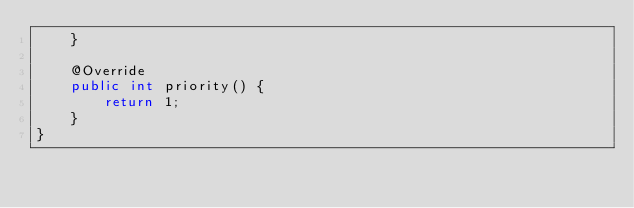Convert code to text. <code><loc_0><loc_0><loc_500><loc_500><_Java_>    }

    @Override
    public int priority() {
        return 1;
    }
}
</code> 